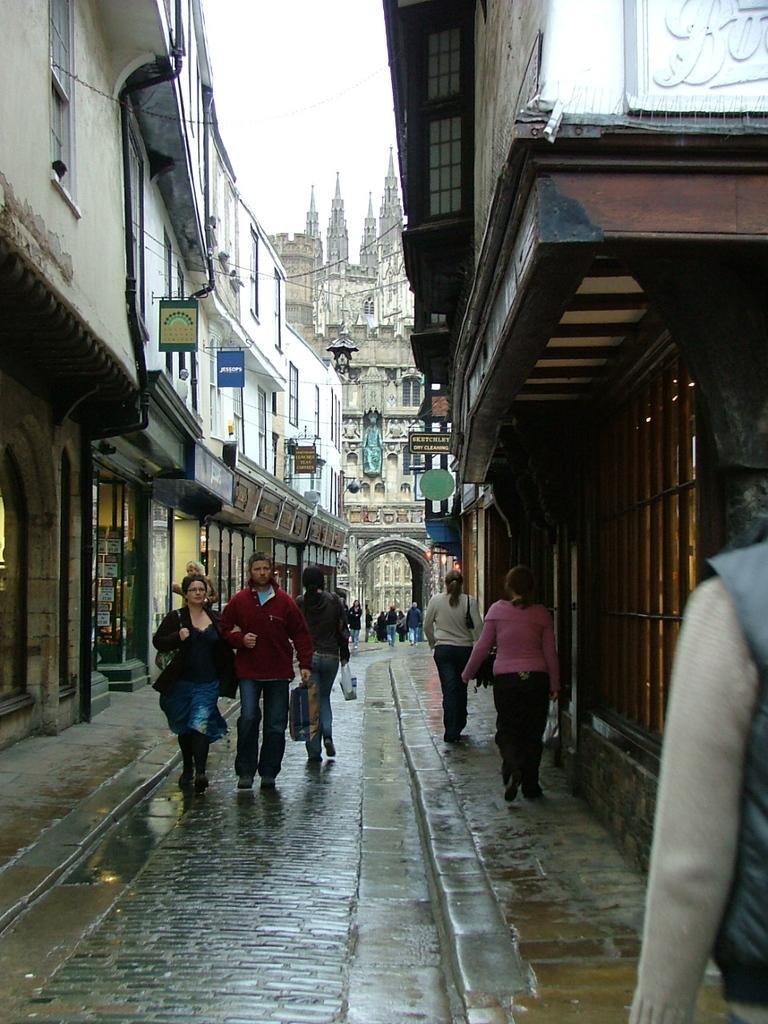Please provide a concise description of this image. In This image on the right side and left side there are some buildings, and some boards. And at the bottom there are some persons walking, and some of them are holding some bags and there is a walkway. In the background there are buildings, and at the top there is sky. 